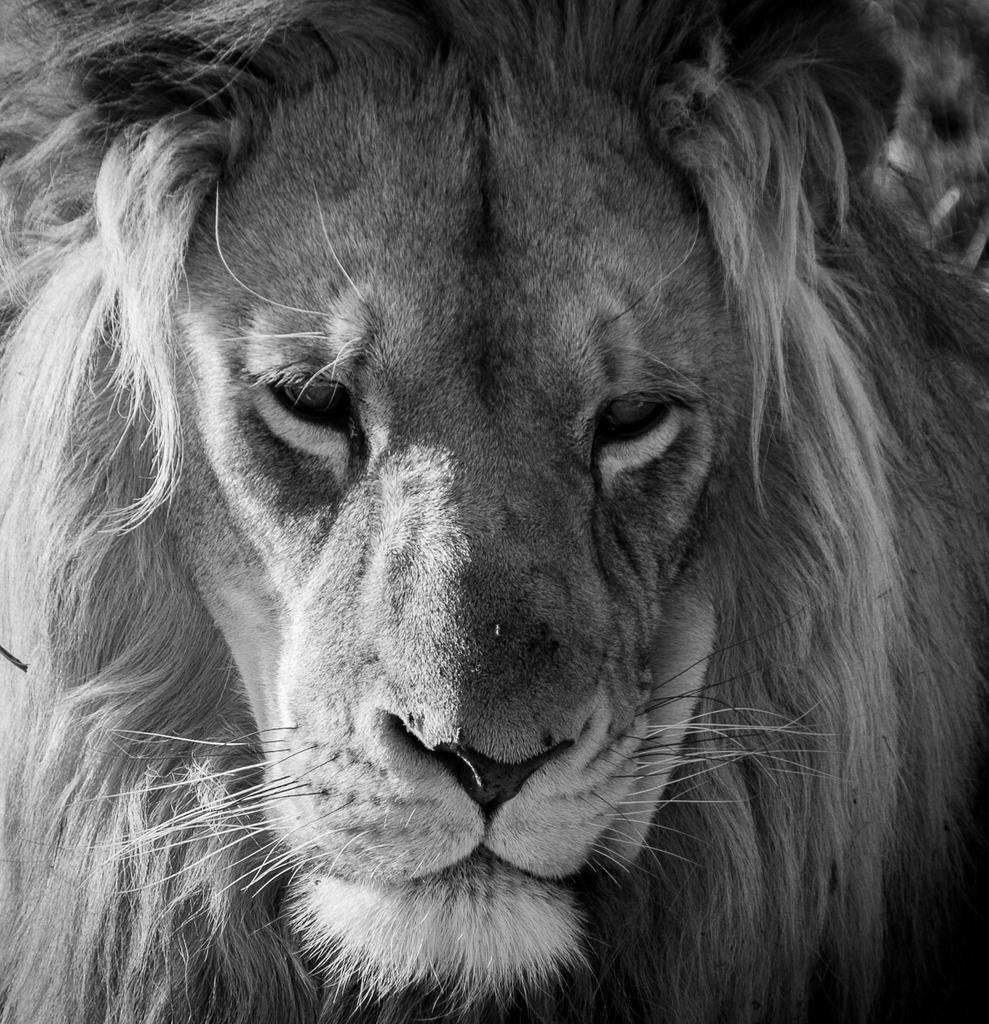What type of animal face is depicted in the image? There is a lion face in the image. What type of organizational structure can be seen in the image? There is no organizational structure present in the image; it features a lion face. What type of system is depicted in the image? There is no system depicted in the image; it features a lion face. 